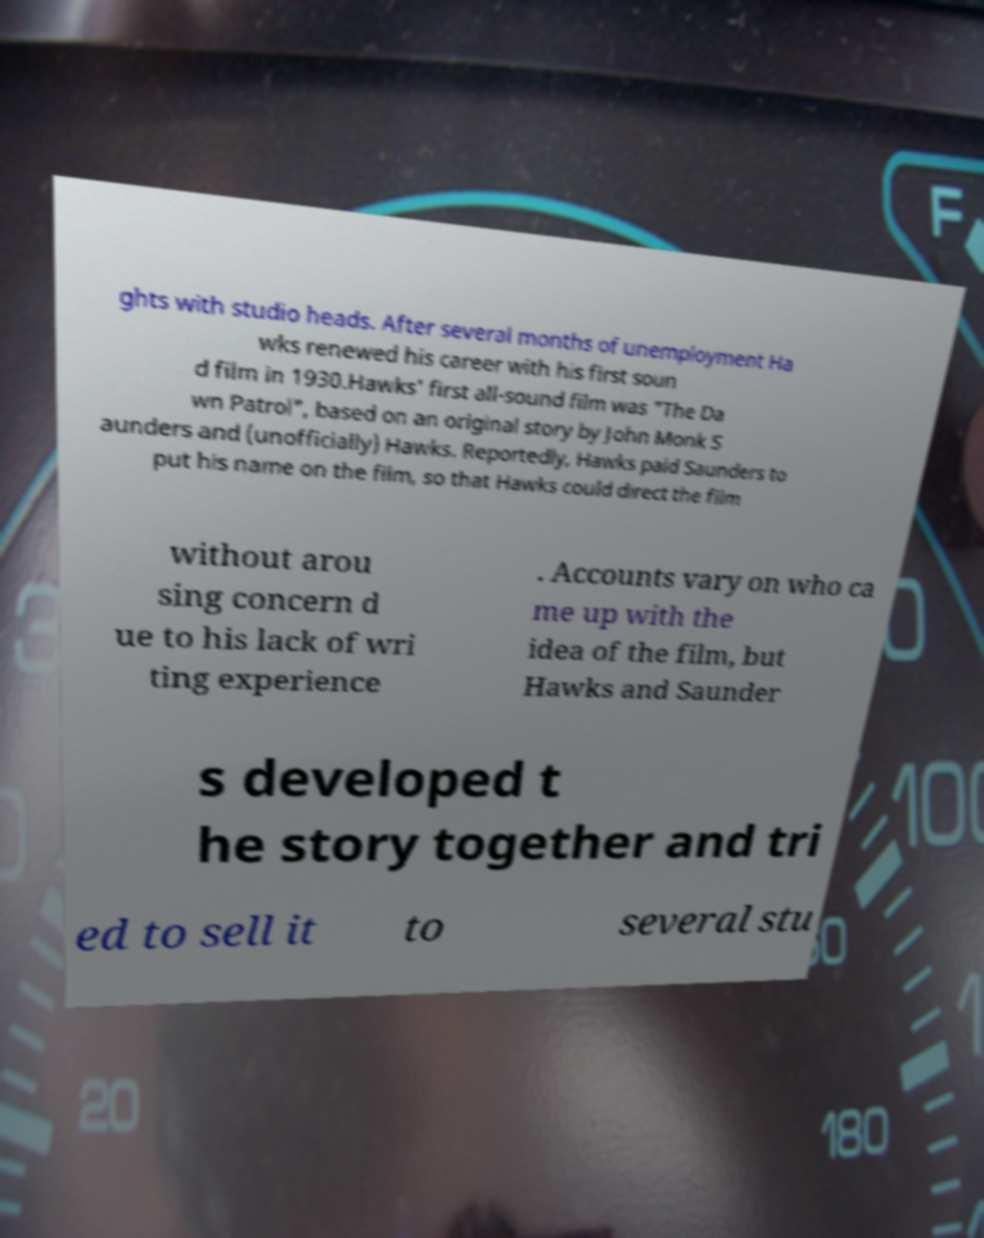Please read and relay the text visible in this image. What does it say? ghts with studio heads. After several months of unemployment Ha wks renewed his career with his first soun d film in 1930.Hawks' first all-sound film was "The Da wn Patrol", based on an original story by John Monk S aunders and (unofficially) Hawks. Reportedly, Hawks paid Saunders to put his name on the film, so that Hawks could direct the film without arou sing concern d ue to his lack of wri ting experience . Accounts vary on who ca me up with the idea of the film, but Hawks and Saunder s developed t he story together and tri ed to sell it to several stu 